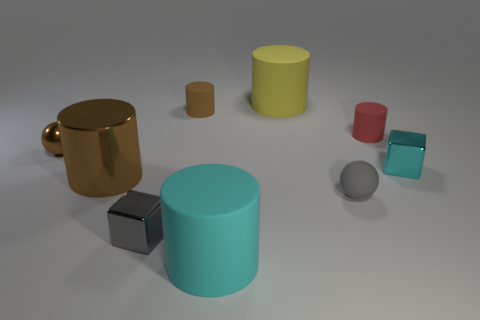Subtract all red cylinders. How many cylinders are left? 4 Subtract all tiny brown matte cylinders. How many cylinders are left? 4 Subtract 2 cylinders. How many cylinders are left? 3 Subtract all purple cylinders. Subtract all brown blocks. How many cylinders are left? 5 Add 1 yellow cylinders. How many objects exist? 10 Subtract all cubes. How many objects are left? 7 Add 6 tiny brown things. How many tiny brown things are left? 8 Add 9 big yellow objects. How many big yellow objects exist? 10 Subtract 0 red cubes. How many objects are left? 9 Subtract all big yellow rubber cylinders. Subtract all brown shiny objects. How many objects are left? 6 